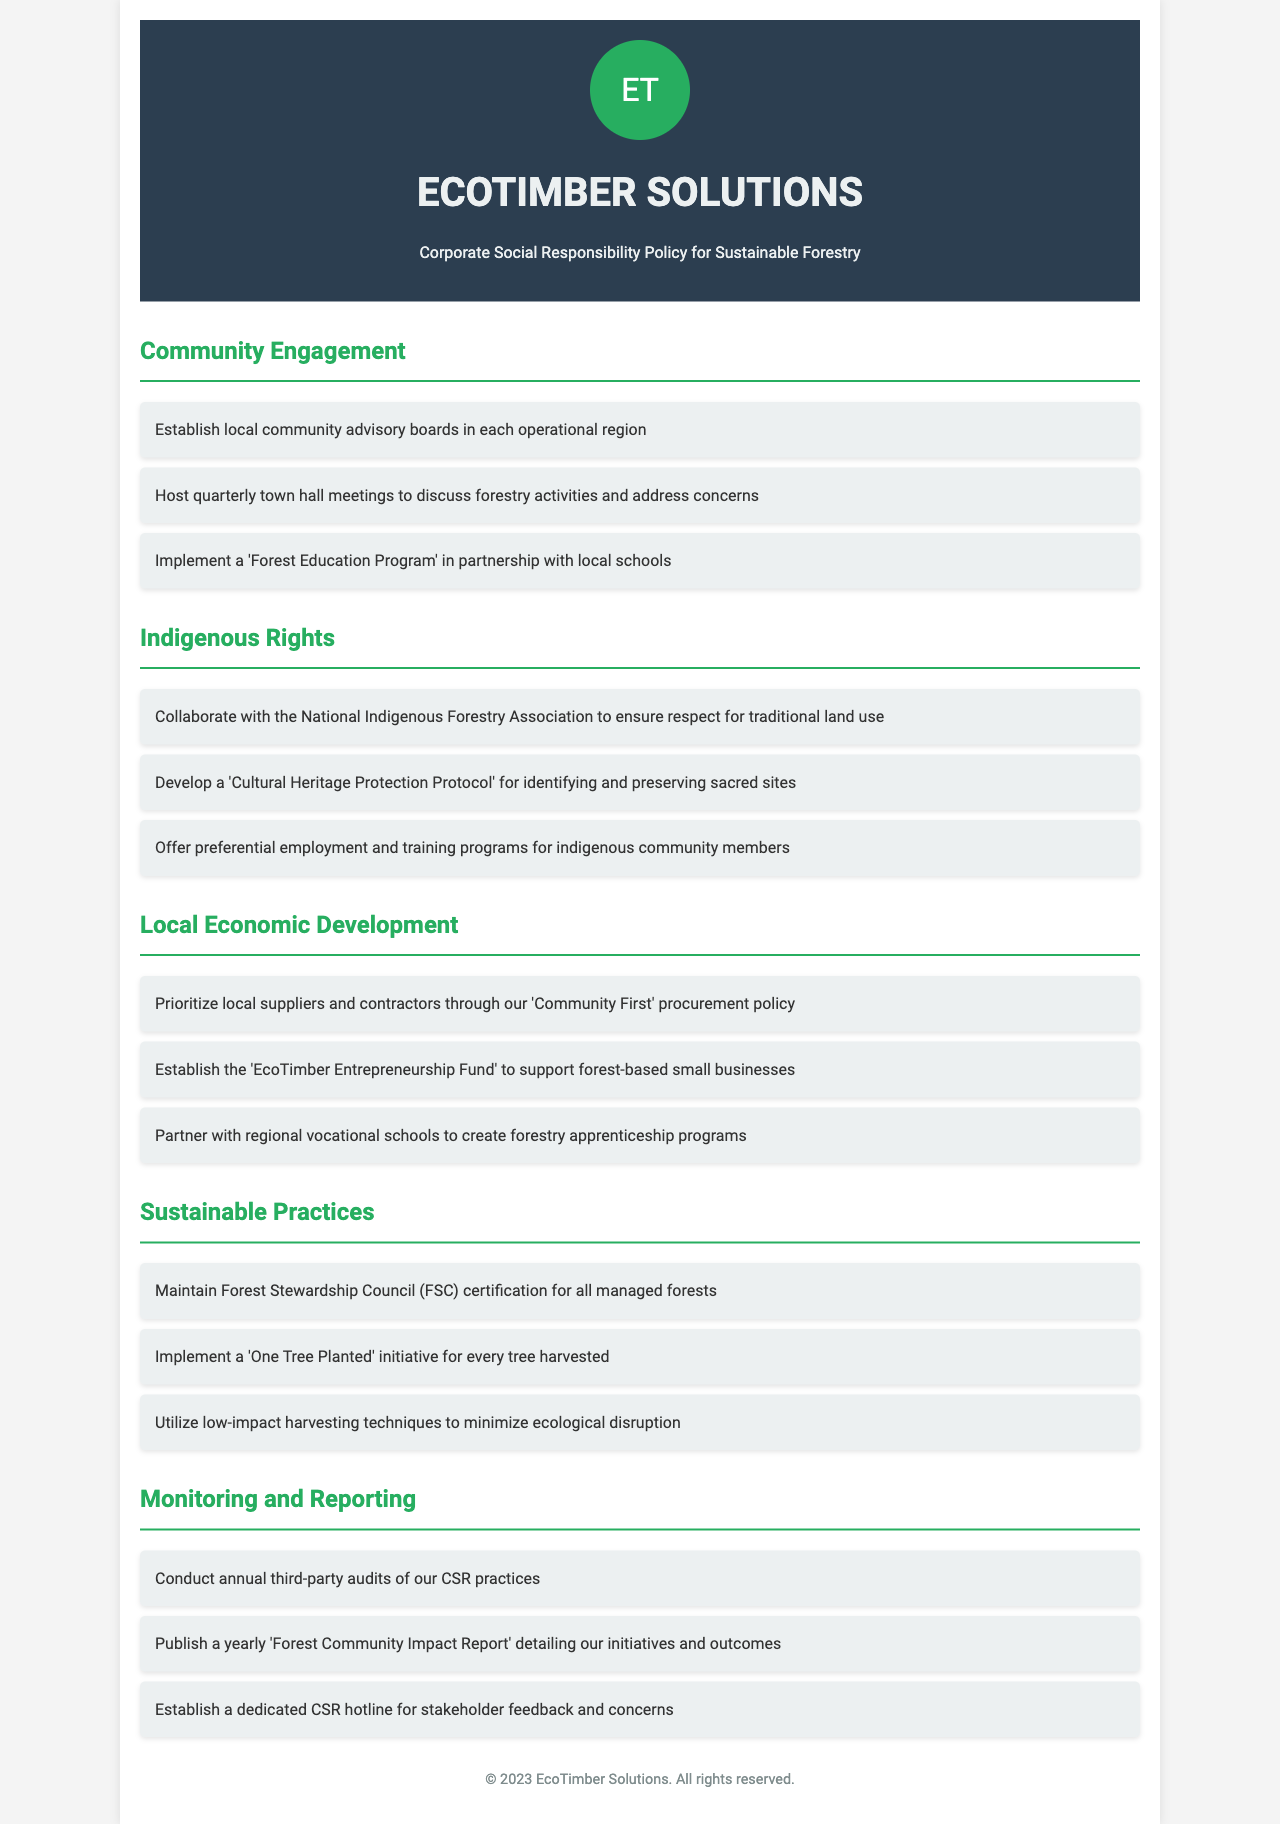What is the name of the forestry company? The name of the forestry company is mentioned in the header of the document.
Answer: EcoTimber Solutions How often are town hall meetings hosted? The document states the frequency of town hall meetings under Community Engagement.
Answer: quarterly What initiative is designed to protect sacred sites? This initiative is detailed under the Indigenous Rights section focused on cultural heritage.
Answer: Cultural Heritage Protection Protocol What program supports forest-based small businesses? The document specifies a fund that aids local entrepreneurship in the Local Economic Development section.
Answer: EcoTimber Entrepreneurship Fund What certification does the company maintain for its forests? This certification is mentioned in the Sustainable Practices section of the document.
Answer: Forest Stewardship Council (FSC) How many audits of CSR practices are conducted annually? The frequency of audits is specified under the Monitoring and Reporting section.
Answer: annual What is the main focus of the 'Forest Education Program'? The purpose of this program is disclosed in the Community Engagement section.
Answer: education Which organization does the company collaborate with for indigenous rights? The specific organization is named in the Indigenous Rights section of the document.
Answer: National Indigenous Forestry Association 